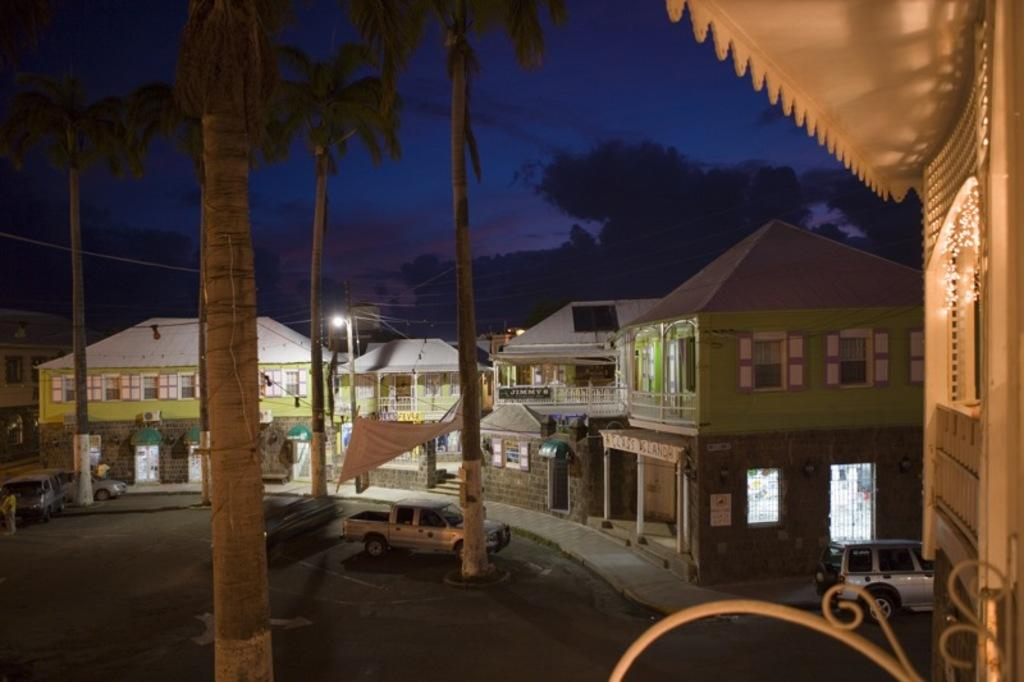What type of natural elements can be seen in the image? There are trees in the image. What type of man-made structures are present in the image? There are buildings in the image. What type of transportation can be seen in the image? There are vehicles in the image. What type of lighting infrastructure is present in the image? There are light poles in the image. What part of the natural environment is visible in the image? The sky is visible in the image. What type of weather can be inferred from the image? There are clouds in the image, suggesting a partly cloudy day. What type of signage is present in the image? There are boards and a banner in the image. Are there any people present in the image? Yes, there is a person in the image. Can you describe any other objects present in the image? There are other objects in the image, but their specific nature is not mentioned in the provided facts. Can you see the ocean in the image? No, there is no ocean present in the image. What type of peace is being promoted by the banner in the image? There is no indication of any peace promotion in the image, as the banner's content is not mentioned in the provided facts. 